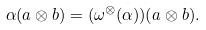Convert formula to latex. <formula><loc_0><loc_0><loc_500><loc_500>\alpha ( a \otimes b ) = ( \omega ^ { \otimes } ( \alpha ) ) ( a \otimes b ) .</formula> 